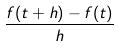Convert formula to latex. <formula><loc_0><loc_0><loc_500><loc_500>\frac { f ( t + h ) - f ( t ) } { h }</formula> 